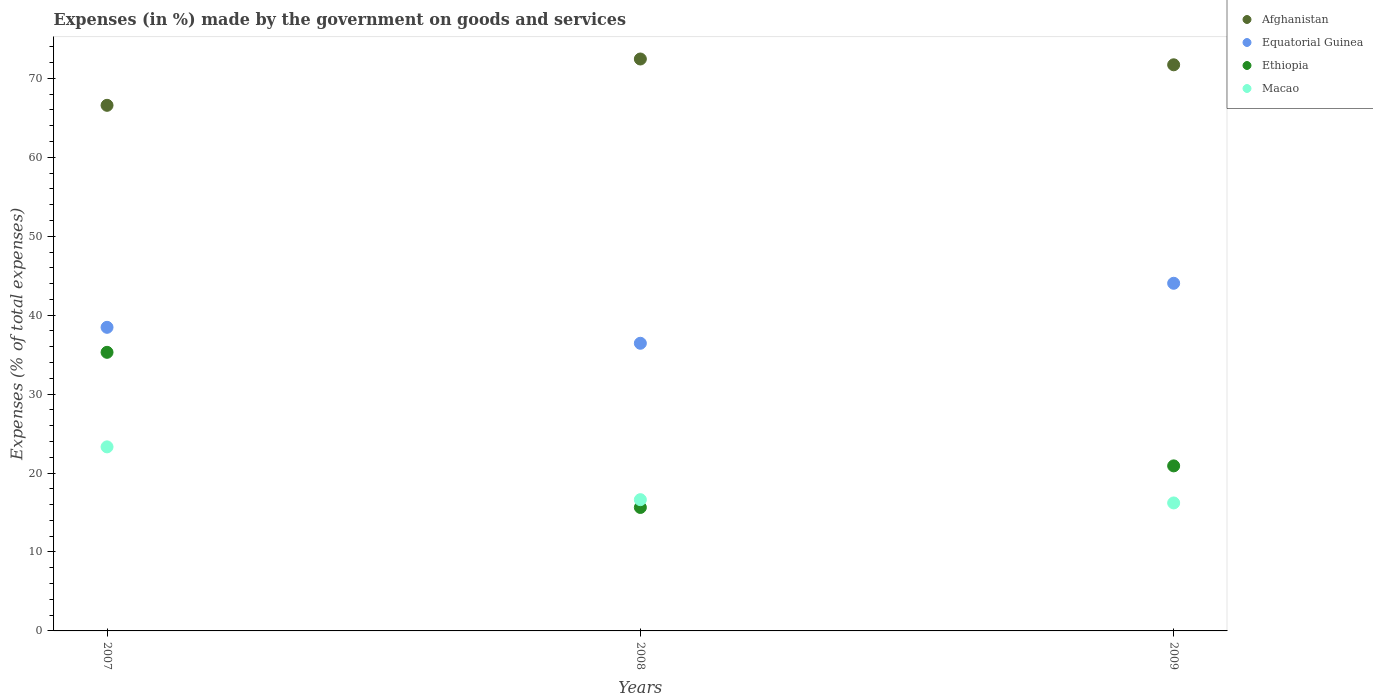Is the number of dotlines equal to the number of legend labels?
Ensure brevity in your answer.  Yes. What is the percentage of expenses made by the government on goods and services in Equatorial Guinea in 2008?
Ensure brevity in your answer.  36.44. Across all years, what is the maximum percentage of expenses made by the government on goods and services in Equatorial Guinea?
Your answer should be compact. 44.04. Across all years, what is the minimum percentage of expenses made by the government on goods and services in Macao?
Your answer should be compact. 16.21. In which year was the percentage of expenses made by the government on goods and services in Ethiopia maximum?
Keep it short and to the point. 2007. What is the total percentage of expenses made by the government on goods and services in Ethiopia in the graph?
Ensure brevity in your answer.  71.85. What is the difference between the percentage of expenses made by the government on goods and services in Macao in 2008 and that in 2009?
Give a very brief answer. 0.41. What is the difference between the percentage of expenses made by the government on goods and services in Macao in 2008 and the percentage of expenses made by the government on goods and services in Afghanistan in 2007?
Provide a succinct answer. -49.96. What is the average percentage of expenses made by the government on goods and services in Afghanistan per year?
Your response must be concise. 70.26. In the year 2007, what is the difference between the percentage of expenses made by the government on goods and services in Equatorial Guinea and percentage of expenses made by the government on goods and services in Afghanistan?
Keep it short and to the point. -28.13. In how many years, is the percentage of expenses made by the government on goods and services in Macao greater than 72 %?
Keep it short and to the point. 0. What is the ratio of the percentage of expenses made by the government on goods and services in Equatorial Guinea in 2008 to that in 2009?
Ensure brevity in your answer.  0.83. Is the difference between the percentage of expenses made by the government on goods and services in Equatorial Guinea in 2007 and 2009 greater than the difference between the percentage of expenses made by the government on goods and services in Afghanistan in 2007 and 2009?
Make the answer very short. No. What is the difference between the highest and the second highest percentage of expenses made by the government on goods and services in Macao?
Ensure brevity in your answer.  6.69. What is the difference between the highest and the lowest percentage of expenses made by the government on goods and services in Ethiopia?
Your answer should be very brief. 19.65. In how many years, is the percentage of expenses made by the government on goods and services in Equatorial Guinea greater than the average percentage of expenses made by the government on goods and services in Equatorial Guinea taken over all years?
Ensure brevity in your answer.  1. Is the sum of the percentage of expenses made by the government on goods and services in Macao in 2007 and 2008 greater than the maximum percentage of expenses made by the government on goods and services in Ethiopia across all years?
Your response must be concise. Yes. Is it the case that in every year, the sum of the percentage of expenses made by the government on goods and services in Equatorial Guinea and percentage of expenses made by the government on goods and services in Macao  is greater than the sum of percentage of expenses made by the government on goods and services in Afghanistan and percentage of expenses made by the government on goods and services in Ethiopia?
Offer a terse response. No. Is the percentage of expenses made by the government on goods and services in Macao strictly greater than the percentage of expenses made by the government on goods and services in Equatorial Guinea over the years?
Keep it short and to the point. No. Is the percentage of expenses made by the government on goods and services in Ethiopia strictly less than the percentage of expenses made by the government on goods and services in Macao over the years?
Offer a terse response. No. How many years are there in the graph?
Give a very brief answer. 3. What is the difference between two consecutive major ticks on the Y-axis?
Your response must be concise. 10. Does the graph contain any zero values?
Ensure brevity in your answer.  No. Does the graph contain grids?
Keep it short and to the point. No. How many legend labels are there?
Your response must be concise. 4. How are the legend labels stacked?
Offer a very short reply. Vertical. What is the title of the graph?
Your response must be concise. Expenses (in %) made by the government on goods and services. Does "Uganda" appear as one of the legend labels in the graph?
Make the answer very short. No. What is the label or title of the Y-axis?
Offer a terse response. Expenses (% of total expenses). What is the Expenses (% of total expenses) in Afghanistan in 2007?
Your response must be concise. 66.59. What is the Expenses (% of total expenses) of Equatorial Guinea in 2007?
Your answer should be very brief. 38.46. What is the Expenses (% of total expenses) in Ethiopia in 2007?
Offer a very short reply. 35.3. What is the Expenses (% of total expenses) in Macao in 2007?
Provide a short and direct response. 23.32. What is the Expenses (% of total expenses) of Afghanistan in 2008?
Offer a terse response. 72.46. What is the Expenses (% of total expenses) in Equatorial Guinea in 2008?
Your answer should be very brief. 36.44. What is the Expenses (% of total expenses) in Ethiopia in 2008?
Offer a very short reply. 15.64. What is the Expenses (% of total expenses) in Macao in 2008?
Ensure brevity in your answer.  16.63. What is the Expenses (% of total expenses) in Afghanistan in 2009?
Keep it short and to the point. 71.72. What is the Expenses (% of total expenses) of Equatorial Guinea in 2009?
Your answer should be very brief. 44.04. What is the Expenses (% of total expenses) in Ethiopia in 2009?
Offer a very short reply. 20.91. What is the Expenses (% of total expenses) in Macao in 2009?
Keep it short and to the point. 16.21. Across all years, what is the maximum Expenses (% of total expenses) in Afghanistan?
Ensure brevity in your answer.  72.46. Across all years, what is the maximum Expenses (% of total expenses) in Equatorial Guinea?
Offer a very short reply. 44.04. Across all years, what is the maximum Expenses (% of total expenses) in Ethiopia?
Make the answer very short. 35.3. Across all years, what is the maximum Expenses (% of total expenses) in Macao?
Your answer should be compact. 23.32. Across all years, what is the minimum Expenses (% of total expenses) in Afghanistan?
Your answer should be compact. 66.59. Across all years, what is the minimum Expenses (% of total expenses) in Equatorial Guinea?
Ensure brevity in your answer.  36.44. Across all years, what is the minimum Expenses (% of total expenses) of Ethiopia?
Make the answer very short. 15.64. Across all years, what is the minimum Expenses (% of total expenses) in Macao?
Give a very brief answer. 16.21. What is the total Expenses (% of total expenses) in Afghanistan in the graph?
Make the answer very short. 210.77. What is the total Expenses (% of total expenses) of Equatorial Guinea in the graph?
Keep it short and to the point. 118.95. What is the total Expenses (% of total expenses) of Ethiopia in the graph?
Provide a succinct answer. 71.85. What is the total Expenses (% of total expenses) in Macao in the graph?
Your answer should be compact. 56.16. What is the difference between the Expenses (% of total expenses) in Afghanistan in 2007 and that in 2008?
Ensure brevity in your answer.  -5.87. What is the difference between the Expenses (% of total expenses) in Equatorial Guinea in 2007 and that in 2008?
Your answer should be very brief. 2.02. What is the difference between the Expenses (% of total expenses) of Ethiopia in 2007 and that in 2008?
Your response must be concise. 19.65. What is the difference between the Expenses (% of total expenses) in Macao in 2007 and that in 2008?
Give a very brief answer. 6.69. What is the difference between the Expenses (% of total expenses) of Afghanistan in 2007 and that in 2009?
Give a very brief answer. -5.13. What is the difference between the Expenses (% of total expenses) in Equatorial Guinea in 2007 and that in 2009?
Your response must be concise. -5.58. What is the difference between the Expenses (% of total expenses) of Ethiopia in 2007 and that in 2009?
Provide a succinct answer. 14.39. What is the difference between the Expenses (% of total expenses) in Macao in 2007 and that in 2009?
Your answer should be very brief. 7.1. What is the difference between the Expenses (% of total expenses) in Afghanistan in 2008 and that in 2009?
Keep it short and to the point. 0.73. What is the difference between the Expenses (% of total expenses) in Equatorial Guinea in 2008 and that in 2009?
Your answer should be very brief. -7.6. What is the difference between the Expenses (% of total expenses) of Ethiopia in 2008 and that in 2009?
Offer a terse response. -5.27. What is the difference between the Expenses (% of total expenses) in Macao in 2008 and that in 2009?
Offer a very short reply. 0.41. What is the difference between the Expenses (% of total expenses) in Afghanistan in 2007 and the Expenses (% of total expenses) in Equatorial Guinea in 2008?
Keep it short and to the point. 30.15. What is the difference between the Expenses (% of total expenses) in Afghanistan in 2007 and the Expenses (% of total expenses) in Ethiopia in 2008?
Your response must be concise. 50.95. What is the difference between the Expenses (% of total expenses) of Afghanistan in 2007 and the Expenses (% of total expenses) of Macao in 2008?
Offer a very short reply. 49.96. What is the difference between the Expenses (% of total expenses) in Equatorial Guinea in 2007 and the Expenses (% of total expenses) in Ethiopia in 2008?
Offer a very short reply. 22.82. What is the difference between the Expenses (% of total expenses) of Equatorial Guinea in 2007 and the Expenses (% of total expenses) of Macao in 2008?
Make the answer very short. 21.84. What is the difference between the Expenses (% of total expenses) in Ethiopia in 2007 and the Expenses (% of total expenses) in Macao in 2008?
Offer a very short reply. 18.67. What is the difference between the Expenses (% of total expenses) in Afghanistan in 2007 and the Expenses (% of total expenses) in Equatorial Guinea in 2009?
Offer a terse response. 22.55. What is the difference between the Expenses (% of total expenses) in Afghanistan in 2007 and the Expenses (% of total expenses) in Ethiopia in 2009?
Offer a very short reply. 45.68. What is the difference between the Expenses (% of total expenses) in Afghanistan in 2007 and the Expenses (% of total expenses) in Macao in 2009?
Keep it short and to the point. 50.38. What is the difference between the Expenses (% of total expenses) in Equatorial Guinea in 2007 and the Expenses (% of total expenses) in Ethiopia in 2009?
Make the answer very short. 17.55. What is the difference between the Expenses (% of total expenses) of Equatorial Guinea in 2007 and the Expenses (% of total expenses) of Macao in 2009?
Give a very brief answer. 22.25. What is the difference between the Expenses (% of total expenses) in Ethiopia in 2007 and the Expenses (% of total expenses) in Macao in 2009?
Keep it short and to the point. 19.08. What is the difference between the Expenses (% of total expenses) in Afghanistan in 2008 and the Expenses (% of total expenses) in Equatorial Guinea in 2009?
Make the answer very short. 28.41. What is the difference between the Expenses (% of total expenses) of Afghanistan in 2008 and the Expenses (% of total expenses) of Ethiopia in 2009?
Your answer should be compact. 51.55. What is the difference between the Expenses (% of total expenses) in Afghanistan in 2008 and the Expenses (% of total expenses) in Macao in 2009?
Make the answer very short. 56.24. What is the difference between the Expenses (% of total expenses) of Equatorial Guinea in 2008 and the Expenses (% of total expenses) of Ethiopia in 2009?
Your answer should be compact. 15.53. What is the difference between the Expenses (% of total expenses) of Equatorial Guinea in 2008 and the Expenses (% of total expenses) of Macao in 2009?
Keep it short and to the point. 20.23. What is the difference between the Expenses (% of total expenses) of Ethiopia in 2008 and the Expenses (% of total expenses) of Macao in 2009?
Keep it short and to the point. -0.57. What is the average Expenses (% of total expenses) in Afghanistan per year?
Your answer should be very brief. 70.26. What is the average Expenses (% of total expenses) in Equatorial Guinea per year?
Ensure brevity in your answer.  39.65. What is the average Expenses (% of total expenses) in Ethiopia per year?
Ensure brevity in your answer.  23.95. What is the average Expenses (% of total expenses) in Macao per year?
Offer a very short reply. 18.72. In the year 2007, what is the difference between the Expenses (% of total expenses) in Afghanistan and Expenses (% of total expenses) in Equatorial Guinea?
Your answer should be very brief. 28.13. In the year 2007, what is the difference between the Expenses (% of total expenses) of Afghanistan and Expenses (% of total expenses) of Ethiopia?
Your response must be concise. 31.29. In the year 2007, what is the difference between the Expenses (% of total expenses) in Afghanistan and Expenses (% of total expenses) in Macao?
Provide a short and direct response. 43.27. In the year 2007, what is the difference between the Expenses (% of total expenses) of Equatorial Guinea and Expenses (% of total expenses) of Ethiopia?
Your answer should be very brief. 3.17. In the year 2007, what is the difference between the Expenses (% of total expenses) of Equatorial Guinea and Expenses (% of total expenses) of Macao?
Provide a succinct answer. 15.15. In the year 2007, what is the difference between the Expenses (% of total expenses) in Ethiopia and Expenses (% of total expenses) in Macao?
Offer a very short reply. 11.98. In the year 2008, what is the difference between the Expenses (% of total expenses) in Afghanistan and Expenses (% of total expenses) in Equatorial Guinea?
Keep it short and to the point. 36.02. In the year 2008, what is the difference between the Expenses (% of total expenses) of Afghanistan and Expenses (% of total expenses) of Ethiopia?
Ensure brevity in your answer.  56.82. In the year 2008, what is the difference between the Expenses (% of total expenses) of Afghanistan and Expenses (% of total expenses) of Macao?
Give a very brief answer. 55.83. In the year 2008, what is the difference between the Expenses (% of total expenses) in Equatorial Guinea and Expenses (% of total expenses) in Ethiopia?
Your response must be concise. 20.8. In the year 2008, what is the difference between the Expenses (% of total expenses) of Equatorial Guinea and Expenses (% of total expenses) of Macao?
Your answer should be compact. 19.81. In the year 2008, what is the difference between the Expenses (% of total expenses) of Ethiopia and Expenses (% of total expenses) of Macao?
Give a very brief answer. -0.99. In the year 2009, what is the difference between the Expenses (% of total expenses) of Afghanistan and Expenses (% of total expenses) of Equatorial Guinea?
Your answer should be very brief. 27.68. In the year 2009, what is the difference between the Expenses (% of total expenses) in Afghanistan and Expenses (% of total expenses) in Ethiopia?
Ensure brevity in your answer.  50.82. In the year 2009, what is the difference between the Expenses (% of total expenses) of Afghanistan and Expenses (% of total expenses) of Macao?
Offer a terse response. 55.51. In the year 2009, what is the difference between the Expenses (% of total expenses) of Equatorial Guinea and Expenses (% of total expenses) of Ethiopia?
Give a very brief answer. 23.14. In the year 2009, what is the difference between the Expenses (% of total expenses) in Equatorial Guinea and Expenses (% of total expenses) in Macao?
Ensure brevity in your answer.  27.83. In the year 2009, what is the difference between the Expenses (% of total expenses) of Ethiopia and Expenses (% of total expenses) of Macao?
Ensure brevity in your answer.  4.69. What is the ratio of the Expenses (% of total expenses) in Afghanistan in 2007 to that in 2008?
Give a very brief answer. 0.92. What is the ratio of the Expenses (% of total expenses) of Equatorial Guinea in 2007 to that in 2008?
Make the answer very short. 1.06. What is the ratio of the Expenses (% of total expenses) in Ethiopia in 2007 to that in 2008?
Offer a terse response. 2.26. What is the ratio of the Expenses (% of total expenses) of Macao in 2007 to that in 2008?
Offer a terse response. 1.4. What is the ratio of the Expenses (% of total expenses) of Afghanistan in 2007 to that in 2009?
Your answer should be compact. 0.93. What is the ratio of the Expenses (% of total expenses) in Equatorial Guinea in 2007 to that in 2009?
Provide a short and direct response. 0.87. What is the ratio of the Expenses (% of total expenses) in Ethiopia in 2007 to that in 2009?
Provide a succinct answer. 1.69. What is the ratio of the Expenses (% of total expenses) of Macao in 2007 to that in 2009?
Make the answer very short. 1.44. What is the ratio of the Expenses (% of total expenses) in Afghanistan in 2008 to that in 2009?
Give a very brief answer. 1.01. What is the ratio of the Expenses (% of total expenses) in Equatorial Guinea in 2008 to that in 2009?
Your answer should be very brief. 0.83. What is the ratio of the Expenses (% of total expenses) of Ethiopia in 2008 to that in 2009?
Your answer should be compact. 0.75. What is the ratio of the Expenses (% of total expenses) in Macao in 2008 to that in 2009?
Keep it short and to the point. 1.03. What is the difference between the highest and the second highest Expenses (% of total expenses) in Afghanistan?
Offer a very short reply. 0.73. What is the difference between the highest and the second highest Expenses (% of total expenses) in Equatorial Guinea?
Provide a short and direct response. 5.58. What is the difference between the highest and the second highest Expenses (% of total expenses) of Ethiopia?
Your response must be concise. 14.39. What is the difference between the highest and the second highest Expenses (% of total expenses) in Macao?
Provide a succinct answer. 6.69. What is the difference between the highest and the lowest Expenses (% of total expenses) in Afghanistan?
Offer a very short reply. 5.87. What is the difference between the highest and the lowest Expenses (% of total expenses) of Equatorial Guinea?
Ensure brevity in your answer.  7.6. What is the difference between the highest and the lowest Expenses (% of total expenses) in Ethiopia?
Provide a short and direct response. 19.65. What is the difference between the highest and the lowest Expenses (% of total expenses) in Macao?
Give a very brief answer. 7.1. 